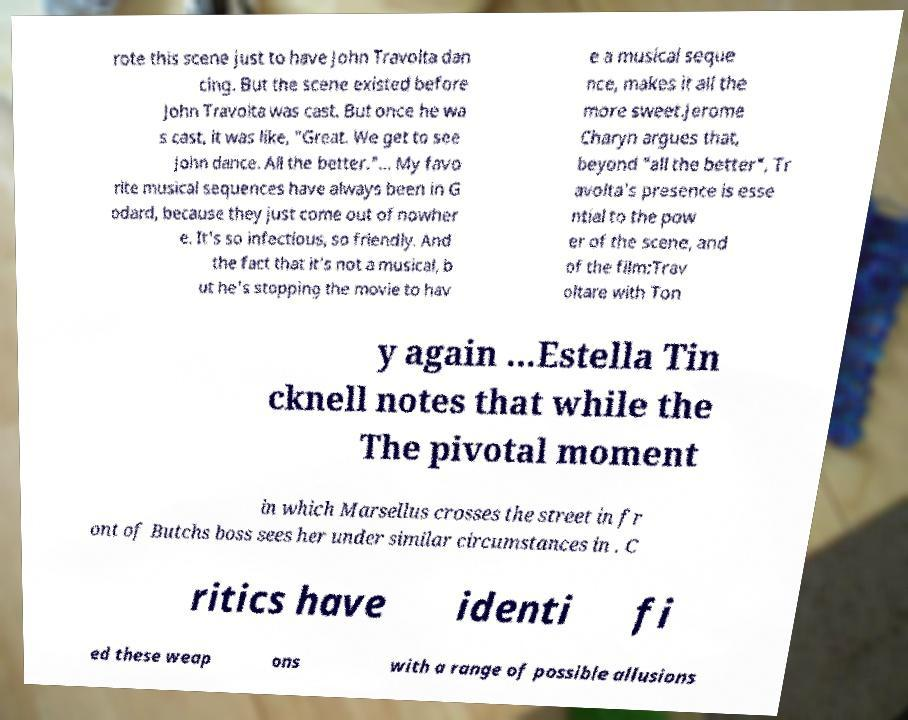What messages or text are displayed in this image? I need them in a readable, typed format. rote this scene just to have John Travolta dan cing. But the scene existed before John Travolta was cast. But once he wa s cast, it was like, "Great. We get to see John dance. All the better."... My favo rite musical sequences have always been in G odard, because they just come out of nowher e. It's so infectious, so friendly. And the fact that it's not a musical, b ut he's stopping the movie to hav e a musical seque nce, makes it all the more sweet.Jerome Charyn argues that, beyond "all the better", Tr avolta's presence is esse ntial to the pow er of the scene, and of the film:Trav oltare with Ton y again ...Estella Tin cknell notes that while the The pivotal moment in which Marsellus crosses the street in fr ont of Butchs boss sees her under similar circumstances in . C ritics have identi fi ed these weap ons with a range of possible allusions 